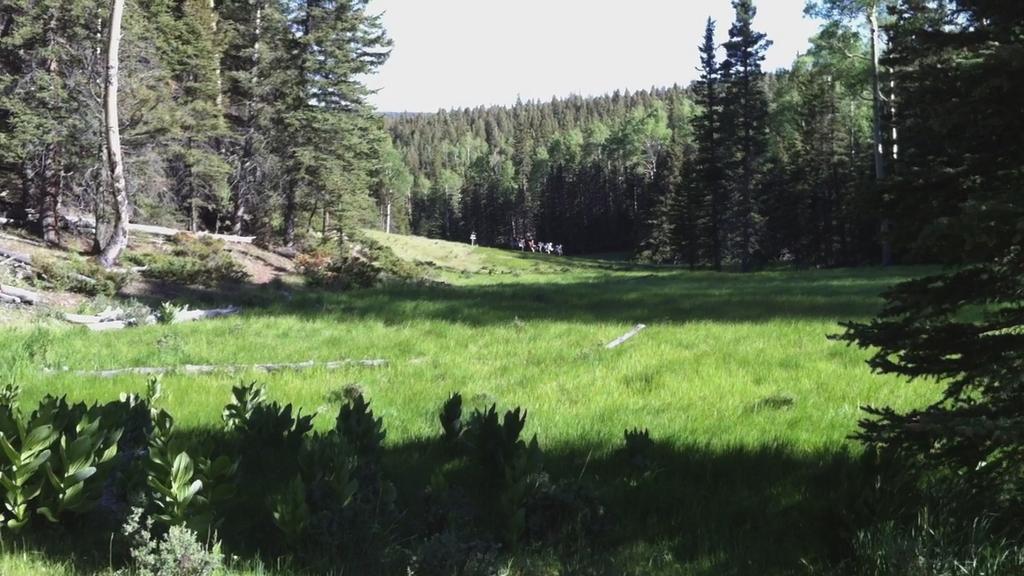Can you describe this image briefly? These are the trees with branches and leaves. Here is the grass, which is green in color. I can see the small bushes. This is the sky. 